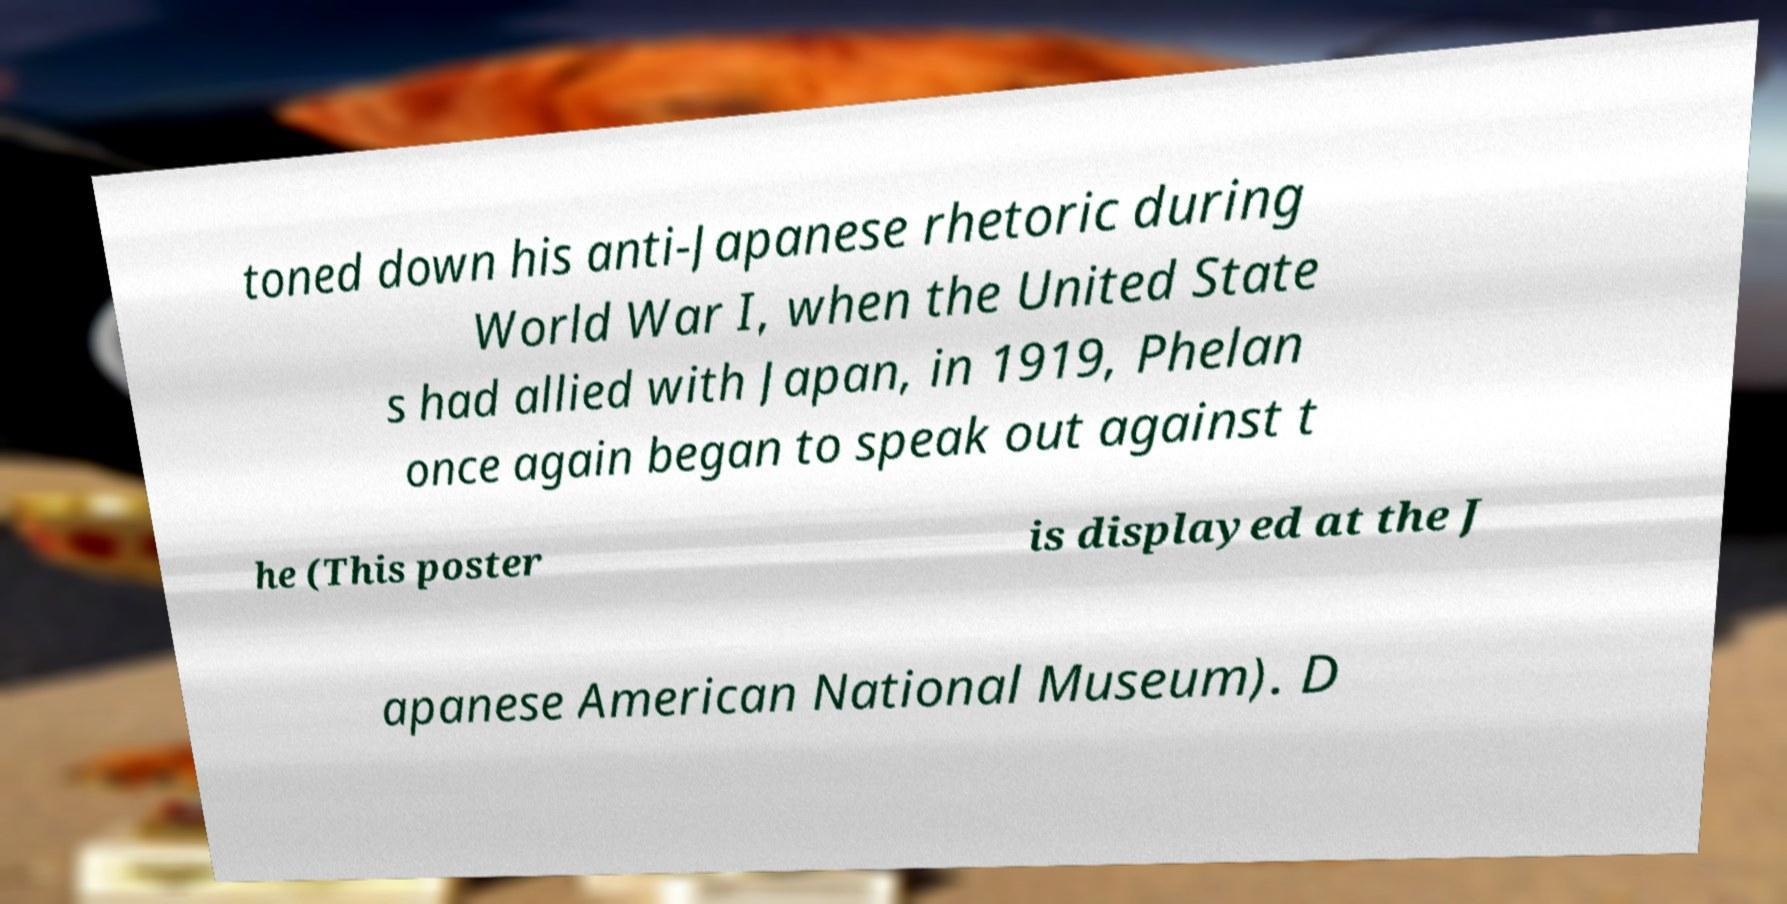I need the written content from this picture converted into text. Can you do that? toned down his anti-Japanese rhetoric during World War I, when the United State s had allied with Japan, in 1919, Phelan once again began to speak out against t he (This poster is displayed at the J apanese American National Museum). D 